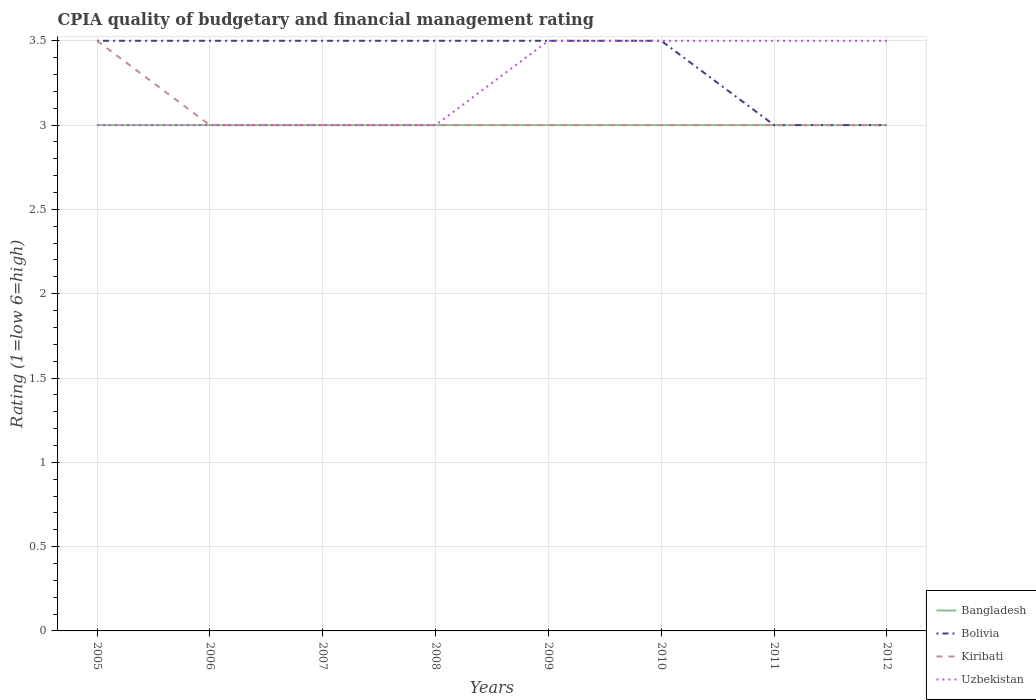How many different coloured lines are there?
Offer a terse response. 4. Does the line corresponding to Uzbekistan intersect with the line corresponding to Bolivia?
Provide a short and direct response. Yes. Across all years, what is the maximum CPIA rating in Kiribati?
Make the answer very short. 3. Is the CPIA rating in Uzbekistan strictly greater than the CPIA rating in Bangladesh over the years?
Provide a succinct answer. No. Are the values on the major ticks of Y-axis written in scientific E-notation?
Offer a terse response. No. Does the graph contain grids?
Provide a succinct answer. Yes. How many legend labels are there?
Provide a succinct answer. 4. What is the title of the graph?
Ensure brevity in your answer.  CPIA quality of budgetary and financial management rating. Does "Argentina" appear as one of the legend labels in the graph?
Make the answer very short. No. What is the label or title of the Y-axis?
Provide a succinct answer. Rating (1=low 6=high). What is the Rating (1=low 6=high) of Bangladesh in 2005?
Provide a succinct answer. 3. What is the Rating (1=low 6=high) in Kiribati in 2005?
Keep it short and to the point. 3.5. What is the Rating (1=low 6=high) of Uzbekistan in 2005?
Ensure brevity in your answer.  3. What is the Rating (1=low 6=high) in Bangladesh in 2006?
Your answer should be very brief. 3. What is the Rating (1=low 6=high) of Uzbekistan in 2006?
Provide a short and direct response. 3. What is the Rating (1=low 6=high) of Bolivia in 2007?
Offer a terse response. 3.5. What is the Rating (1=low 6=high) of Kiribati in 2009?
Give a very brief answer. 3. What is the Rating (1=low 6=high) of Uzbekistan in 2009?
Provide a short and direct response. 3.5. What is the Rating (1=low 6=high) in Bangladesh in 2011?
Make the answer very short. 3. What is the Rating (1=low 6=high) in Kiribati in 2011?
Provide a succinct answer. 3. What is the Rating (1=low 6=high) of Bangladesh in 2012?
Your answer should be very brief. 3. What is the Rating (1=low 6=high) in Bolivia in 2012?
Offer a terse response. 3. Across all years, what is the maximum Rating (1=low 6=high) in Bangladesh?
Your response must be concise. 3. Across all years, what is the maximum Rating (1=low 6=high) in Bolivia?
Ensure brevity in your answer.  3.5. What is the total Rating (1=low 6=high) of Bangladesh in the graph?
Provide a short and direct response. 24. What is the total Rating (1=low 6=high) in Kiribati in the graph?
Provide a short and direct response. 24.5. What is the total Rating (1=low 6=high) in Uzbekistan in the graph?
Offer a very short reply. 26. What is the difference between the Rating (1=low 6=high) of Bangladesh in 2005 and that in 2006?
Your answer should be compact. 0. What is the difference between the Rating (1=low 6=high) in Bolivia in 2005 and that in 2007?
Keep it short and to the point. 0. What is the difference between the Rating (1=low 6=high) of Kiribati in 2005 and that in 2007?
Provide a short and direct response. 0.5. What is the difference between the Rating (1=low 6=high) of Bangladesh in 2005 and that in 2008?
Provide a succinct answer. 0. What is the difference between the Rating (1=low 6=high) in Uzbekistan in 2005 and that in 2008?
Ensure brevity in your answer.  0. What is the difference between the Rating (1=low 6=high) of Bangladesh in 2005 and that in 2009?
Provide a short and direct response. 0. What is the difference between the Rating (1=low 6=high) of Uzbekistan in 2005 and that in 2009?
Provide a succinct answer. -0.5. What is the difference between the Rating (1=low 6=high) in Kiribati in 2005 and that in 2010?
Provide a succinct answer. 0.5. What is the difference between the Rating (1=low 6=high) in Uzbekistan in 2005 and that in 2010?
Ensure brevity in your answer.  -0.5. What is the difference between the Rating (1=low 6=high) of Uzbekistan in 2005 and that in 2011?
Offer a very short reply. -0.5. What is the difference between the Rating (1=low 6=high) in Bangladesh in 2005 and that in 2012?
Your answer should be compact. 0. What is the difference between the Rating (1=low 6=high) of Bolivia in 2005 and that in 2012?
Provide a short and direct response. 0.5. What is the difference between the Rating (1=low 6=high) of Bangladesh in 2006 and that in 2007?
Offer a very short reply. 0. What is the difference between the Rating (1=low 6=high) in Bolivia in 2006 and that in 2007?
Offer a terse response. 0. What is the difference between the Rating (1=low 6=high) of Kiribati in 2006 and that in 2007?
Keep it short and to the point. 0. What is the difference between the Rating (1=low 6=high) in Kiribati in 2006 and that in 2008?
Ensure brevity in your answer.  0. What is the difference between the Rating (1=low 6=high) in Uzbekistan in 2006 and that in 2008?
Offer a very short reply. 0. What is the difference between the Rating (1=low 6=high) in Bangladesh in 2006 and that in 2009?
Offer a very short reply. 0. What is the difference between the Rating (1=low 6=high) of Bolivia in 2006 and that in 2009?
Offer a terse response. 0. What is the difference between the Rating (1=low 6=high) in Uzbekistan in 2006 and that in 2009?
Your response must be concise. -0.5. What is the difference between the Rating (1=low 6=high) in Bolivia in 2006 and that in 2010?
Ensure brevity in your answer.  0. What is the difference between the Rating (1=low 6=high) in Uzbekistan in 2006 and that in 2011?
Keep it short and to the point. -0.5. What is the difference between the Rating (1=low 6=high) in Bangladesh in 2006 and that in 2012?
Your answer should be compact. 0. What is the difference between the Rating (1=low 6=high) of Kiribati in 2006 and that in 2012?
Offer a terse response. 0. What is the difference between the Rating (1=low 6=high) in Bangladesh in 2007 and that in 2008?
Offer a terse response. 0. What is the difference between the Rating (1=low 6=high) in Bolivia in 2007 and that in 2008?
Your response must be concise. 0. What is the difference between the Rating (1=low 6=high) in Uzbekistan in 2007 and that in 2008?
Ensure brevity in your answer.  0. What is the difference between the Rating (1=low 6=high) of Bolivia in 2007 and that in 2009?
Provide a succinct answer. 0. What is the difference between the Rating (1=low 6=high) of Kiribati in 2007 and that in 2009?
Your response must be concise. 0. What is the difference between the Rating (1=low 6=high) in Uzbekistan in 2007 and that in 2009?
Your response must be concise. -0.5. What is the difference between the Rating (1=low 6=high) of Kiribati in 2007 and that in 2010?
Make the answer very short. 0. What is the difference between the Rating (1=low 6=high) of Bangladesh in 2007 and that in 2011?
Your answer should be very brief. 0. What is the difference between the Rating (1=low 6=high) of Bolivia in 2007 and that in 2011?
Keep it short and to the point. 0.5. What is the difference between the Rating (1=low 6=high) of Kiribati in 2007 and that in 2011?
Offer a terse response. 0. What is the difference between the Rating (1=low 6=high) of Uzbekistan in 2007 and that in 2011?
Your response must be concise. -0.5. What is the difference between the Rating (1=low 6=high) of Bangladesh in 2007 and that in 2012?
Your answer should be very brief. 0. What is the difference between the Rating (1=low 6=high) of Bolivia in 2007 and that in 2012?
Give a very brief answer. 0.5. What is the difference between the Rating (1=low 6=high) of Kiribati in 2007 and that in 2012?
Provide a short and direct response. 0. What is the difference between the Rating (1=low 6=high) of Bolivia in 2008 and that in 2009?
Ensure brevity in your answer.  0. What is the difference between the Rating (1=low 6=high) in Kiribati in 2008 and that in 2009?
Give a very brief answer. 0. What is the difference between the Rating (1=low 6=high) of Uzbekistan in 2008 and that in 2009?
Ensure brevity in your answer.  -0.5. What is the difference between the Rating (1=low 6=high) in Uzbekistan in 2008 and that in 2010?
Your response must be concise. -0.5. What is the difference between the Rating (1=low 6=high) in Bangladesh in 2008 and that in 2011?
Provide a short and direct response. 0. What is the difference between the Rating (1=low 6=high) of Uzbekistan in 2008 and that in 2011?
Provide a succinct answer. -0.5. What is the difference between the Rating (1=low 6=high) in Bolivia in 2008 and that in 2012?
Make the answer very short. 0.5. What is the difference between the Rating (1=low 6=high) of Bolivia in 2009 and that in 2010?
Ensure brevity in your answer.  0. What is the difference between the Rating (1=low 6=high) in Bangladesh in 2009 and that in 2011?
Ensure brevity in your answer.  0. What is the difference between the Rating (1=low 6=high) of Bolivia in 2009 and that in 2011?
Keep it short and to the point. 0.5. What is the difference between the Rating (1=low 6=high) of Uzbekistan in 2009 and that in 2011?
Make the answer very short. 0. What is the difference between the Rating (1=low 6=high) of Bangladesh in 2009 and that in 2012?
Provide a short and direct response. 0. What is the difference between the Rating (1=low 6=high) in Bolivia in 2009 and that in 2012?
Provide a short and direct response. 0.5. What is the difference between the Rating (1=low 6=high) of Uzbekistan in 2009 and that in 2012?
Offer a terse response. 0. What is the difference between the Rating (1=low 6=high) in Bolivia in 2010 and that in 2011?
Provide a succinct answer. 0.5. What is the difference between the Rating (1=low 6=high) of Kiribati in 2010 and that in 2011?
Ensure brevity in your answer.  0. What is the difference between the Rating (1=low 6=high) in Uzbekistan in 2010 and that in 2011?
Offer a very short reply. 0. What is the difference between the Rating (1=low 6=high) in Kiribati in 2010 and that in 2012?
Make the answer very short. 0. What is the difference between the Rating (1=low 6=high) in Uzbekistan in 2010 and that in 2012?
Ensure brevity in your answer.  0. What is the difference between the Rating (1=low 6=high) of Bangladesh in 2011 and that in 2012?
Provide a short and direct response. 0. What is the difference between the Rating (1=low 6=high) in Bolivia in 2011 and that in 2012?
Offer a very short reply. 0. What is the difference between the Rating (1=low 6=high) in Uzbekistan in 2011 and that in 2012?
Provide a succinct answer. 0. What is the difference between the Rating (1=low 6=high) in Bangladesh in 2005 and the Rating (1=low 6=high) in Bolivia in 2006?
Your answer should be compact. -0.5. What is the difference between the Rating (1=low 6=high) in Bangladesh in 2005 and the Rating (1=low 6=high) in Kiribati in 2006?
Make the answer very short. 0. What is the difference between the Rating (1=low 6=high) of Bangladesh in 2005 and the Rating (1=low 6=high) of Uzbekistan in 2006?
Your answer should be compact. 0. What is the difference between the Rating (1=low 6=high) in Bolivia in 2005 and the Rating (1=low 6=high) in Uzbekistan in 2006?
Offer a very short reply. 0.5. What is the difference between the Rating (1=low 6=high) in Kiribati in 2005 and the Rating (1=low 6=high) in Uzbekistan in 2006?
Provide a short and direct response. 0.5. What is the difference between the Rating (1=low 6=high) in Bangladesh in 2005 and the Rating (1=low 6=high) in Bolivia in 2007?
Keep it short and to the point. -0.5. What is the difference between the Rating (1=low 6=high) in Bolivia in 2005 and the Rating (1=low 6=high) in Kiribati in 2007?
Your answer should be very brief. 0.5. What is the difference between the Rating (1=low 6=high) in Bangladesh in 2005 and the Rating (1=low 6=high) in Kiribati in 2008?
Offer a terse response. 0. What is the difference between the Rating (1=low 6=high) in Bolivia in 2005 and the Rating (1=low 6=high) in Kiribati in 2008?
Your answer should be compact. 0.5. What is the difference between the Rating (1=low 6=high) of Bangladesh in 2005 and the Rating (1=low 6=high) of Kiribati in 2009?
Your answer should be compact. 0. What is the difference between the Rating (1=low 6=high) of Bangladesh in 2005 and the Rating (1=low 6=high) of Uzbekistan in 2009?
Keep it short and to the point. -0.5. What is the difference between the Rating (1=low 6=high) in Bolivia in 2005 and the Rating (1=low 6=high) in Uzbekistan in 2009?
Keep it short and to the point. 0. What is the difference between the Rating (1=low 6=high) in Bangladesh in 2005 and the Rating (1=low 6=high) in Kiribati in 2010?
Your response must be concise. 0. What is the difference between the Rating (1=low 6=high) in Bolivia in 2005 and the Rating (1=low 6=high) in Kiribati in 2010?
Your answer should be very brief. 0.5. What is the difference between the Rating (1=low 6=high) of Bolivia in 2005 and the Rating (1=low 6=high) of Uzbekistan in 2010?
Offer a terse response. 0. What is the difference between the Rating (1=low 6=high) in Bangladesh in 2005 and the Rating (1=low 6=high) in Bolivia in 2011?
Ensure brevity in your answer.  0. What is the difference between the Rating (1=low 6=high) in Bangladesh in 2005 and the Rating (1=low 6=high) in Kiribati in 2011?
Offer a terse response. 0. What is the difference between the Rating (1=low 6=high) of Bolivia in 2005 and the Rating (1=low 6=high) of Kiribati in 2011?
Offer a terse response. 0.5. What is the difference between the Rating (1=low 6=high) in Kiribati in 2005 and the Rating (1=low 6=high) in Uzbekistan in 2011?
Ensure brevity in your answer.  0. What is the difference between the Rating (1=low 6=high) in Bangladesh in 2005 and the Rating (1=low 6=high) in Bolivia in 2012?
Offer a very short reply. 0. What is the difference between the Rating (1=low 6=high) of Bangladesh in 2005 and the Rating (1=low 6=high) of Uzbekistan in 2012?
Provide a succinct answer. -0.5. What is the difference between the Rating (1=low 6=high) of Bolivia in 2005 and the Rating (1=low 6=high) of Uzbekistan in 2012?
Offer a terse response. 0. What is the difference between the Rating (1=low 6=high) of Kiribati in 2005 and the Rating (1=low 6=high) of Uzbekistan in 2012?
Offer a terse response. 0. What is the difference between the Rating (1=low 6=high) of Bangladesh in 2006 and the Rating (1=low 6=high) of Uzbekistan in 2007?
Your response must be concise. 0. What is the difference between the Rating (1=low 6=high) of Bolivia in 2006 and the Rating (1=low 6=high) of Kiribati in 2007?
Offer a terse response. 0.5. What is the difference between the Rating (1=low 6=high) of Bolivia in 2006 and the Rating (1=low 6=high) of Uzbekistan in 2007?
Your answer should be very brief. 0.5. What is the difference between the Rating (1=low 6=high) of Bangladesh in 2006 and the Rating (1=low 6=high) of Bolivia in 2008?
Make the answer very short. -0.5. What is the difference between the Rating (1=low 6=high) of Bangladesh in 2006 and the Rating (1=low 6=high) of Uzbekistan in 2008?
Offer a terse response. 0. What is the difference between the Rating (1=low 6=high) of Bolivia in 2006 and the Rating (1=low 6=high) of Kiribati in 2008?
Your answer should be very brief. 0.5. What is the difference between the Rating (1=low 6=high) in Bolivia in 2006 and the Rating (1=low 6=high) in Uzbekistan in 2008?
Your answer should be very brief. 0.5. What is the difference between the Rating (1=low 6=high) in Bangladesh in 2006 and the Rating (1=low 6=high) in Bolivia in 2009?
Offer a terse response. -0.5. What is the difference between the Rating (1=low 6=high) in Bangladesh in 2006 and the Rating (1=low 6=high) in Kiribati in 2009?
Your answer should be very brief. 0. What is the difference between the Rating (1=low 6=high) of Bolivia in 2006 and the Rating (1=low 6=high) of Uzbekistan in 2009?
Provide a succinct answer. 0. What is the difference between the Rating (1=low 6=high) of Kiribati in 2006 and the Rating (1=low 6=high) of Uzbekistan in 2009?
Give a very brief answer. -0.5. What is the difference between the Rating (1=low 6=high) of Bolivia in 2006 and the Rating (1=low 6=high) of Uzbekistan in 2010?
Make the answer very short. 0. What is the difference between the Rating (1=low 6=high) in Bangladesh in 2006 and the Rating (1=low 6=high) in Kiribati in 2011?
Keep it short and to the point. 0. What is the difference between the Rating (1=low 6=high) in Bangladesh in 2006 and the Rating (1=low 6=high) in Uzbekistan in 2011?
Offer a very short reply. -0.5. What is the difference between the Rating (1=low 6=high) in Bolivia in 2006 and the Rating (1=low 6=high) in Kiribati in 2011?
Your answer should be compact. 0.5. What is the difference between the Rating (1=low 6=high) of Bolivia in 2006 and the Rating (1=low 6=high) of Uzbekistan in 2011?
Keep it short and to the point. 0. What is the difference between the Rating (1=low 6=high) in Bangladesh in 2006 and the Rating (1=low 6=high) in Kiribati in 2012?
Make the answer very short. 0. What is the difference between the Rating (1=low 6=high) of Bangladesh in 2006 and the Rating (1=low 6=high) of Uzbekistan in 2012?
Your response must be concise. -0.5. What is the difference between the Rating (1=low 6=high) of Bolivia in 2006 and the Rating (1=low 6=high) of Kiribati in 2012?
Ensure brevity in your answer.  0.5. What is the difference between the Rating (1=low 6=high) of Bolivia in 2006 and the Rating (1=low 6=high) of Uzbekistan in 2012?
Make the answer very short. 0. What is the difference between the Rating (1=low 6=high) in Kiribati in 2007 and the Rating (1=low 6=high) in Uzbekistan in 2008?
Your answer should be very brief. 0. What is the difference between the Rating (1=low 6=high) in Bangladesh in 2007 and the Rating (1=low 6=high) in Bolivia in 2009?
Keep it short and to the point. -0.5. What is the difference between the Rating (1=low 6=high) of Bangladesh in 2007 and the Rating (1=low 6=high) of Kiribati in 2009?
Your answer should be very brief. 0. What is the difference between the Rating (1=low 6=high) of Bangladesh in 2007 and the Rating (1=low 6=high) of Uzbekistan in 2009?
Your answer should be compact. -0.5. What is the difference between the Rating (1=low 6=high) in Bangladesh in 2007 and the Rating (1=low 6=high) in Uzbekistan in 2010?
Offer a very short reply. -0.5. What is the difference between the Rating (1=low 6=high) of Bolivia in 2007 and the Rating (1=low 6=high) of Uzbekistan in 2010?
Offer a very short reply. 0. What is the difference between the Rating (1=low 6=high) in Bangladesh in 2007 and the Rating (1=low 6=high) in Bolivia in 2011?
Offer a very short reply. 0. What is the difference between the Rating (1=low 6=high) of Bangladesh in 2007 and the Rating (1=low 6=high) of Kiribati in 2011?
Keep it short and to the point. 0. What is the difference between the Rating (1=low 6=high) in Bolivia in 2007 and the Rating (1=low 6=high) in Uzbekistan in 2011?
Keep it short and to the point. 0. What is the difference between the Rating (1=low 6=high) of Bangladesh in 2007 and the Rating (1=low 6=high) of Bolivia in 2012?
Provide a succinct answer. 0. What is the difference between the Rating (1=low 6=high) in Bangladesh in 2007 and the Rating (1=low 6=high) in Uzbekistan in 2012?
Your answer should be very brief. -0.5. What is the difference between the Rating (1=low 6=high) of Bolivia in 2007 and the Rating (1=low 6=high) of Kiribati in 2012?
Offer a very short reply. 0.5. What is the difference between the Rating (1=low 6=high) in Bolivia in 2007 and the Rating (1=low 6=high) in Uzbekistan in 2012?
Your answer should be very brief. 0. What is the difference between the Rating (1=low 6=high) of Bangladesh in 2008 and the Rating (1=low 6=high) of Bolivia in 2009?
Ensure brevity in your answer.  -0.5. What is the difference between the Rating (1=low 6=high) in Bangladesh in 2008 and the Rating (1=low 6=high) in Kiribati in 2009?
Your answer should be very brief. 0. What is the difference between the Rating (1=low 6=high) of Bangladesh in 2008 and the Rating (1=low 6=high) of Uzbekistan in 2009?
Keep it short and to the point. -0.5. What is the difference between the Rating (1=low 6=high) of Bolivia in 2008 and the Rating (1=low 6=high) of Kiribati in 2009?
Offer a terse response. 0.5. What is the difference between the Rating (1=low 6=high) of Bolivia in 2008 and the Rating (1=low 6=high) of Uzbekistan in 2009?
Make the answer very short. 0. What is the difference between the Rating (1=low 6=high) of Kiribati in 2008 and the Rating (1=low 6=high) of Uzbekistan in 2009?
Keep it short and to the point. -0.5. What is the difference between the Rating (1=low 6=high) of Bangladesh in 2008 and the Rating (1=low 6=high) of Bolivia in 2010?
Give a very brief answer. -0.5. What is the difference between the Rating (1=low 6=high) of Bangladesh in 2008 and the Rating (1=low 6=high) of Kiribati in 2010?
Keep it short and to the point. 0. What is the difference between the Rating (1=low 6=high) in Kiribati in 2008 and the Rating (1=low 6=high) in Uzbekistan in 2010?
Keep it short and to the point. -0.5. What is the difference between the Rating (1=low 6=high) in Bangladesh in 2008 and the Rating (1=low 6=high) in Bolivia in 2011?
Your answer should be very brief. 0. What is the difference between the Rating (1=low 6=high) of Bangladesh in 2008 and the Rating (1=low 6=high) of Uzbekistan in 2011?
Make the answer very short. -0.5. What is the difference between the Rating (1=low 6=high) of Bolivia in 2008 and the Rating (1=low 6=high) of Uzbekistan in 2011?
Provide a short and direct response. 0. What is the difference between the Rating (1=low 6=high) of Kiribati in 2008 and the Rating (1=low 6=high) of Uzbekistan in 2011?
Your response must be concise. -0.5. What is the difference between the Rating (1=low 6=high) in Bangladesh in 2008 and the Rating (1=low 6=high) in Uzbekistan in 2012?
Your answer should be very brief. -0.5. What is the difference between the Rating (1=low 6=high) of Bolivia in 2008 and the Rating (1=low 6=high) of Uzbekistan in 2012?
Make the answer very short. 0. What is the difference between the Rating (1=low 6=high) in Bangladesh in 2009 and the Rating (1=low 6=high) in Kiribati in 2010?
Provide a succinct answer. 0. What is the difference between the Rating (1=low 6=high) of Bolivia in 2009 and the Rating (1=low 6=high) of Uzbekistan in 2010?
Keep it short and to the point. 0. What is the difference between the Rating (1=low 6=high) of Kiribati in 2009 and the Rating (1=low 6=high) of Uzbekistan in 2010?
Offer a very short reply. -0.5. What is the difference between the Rating (1=low 6=high) of Bangladesh in 2009 and the Rating (1=low 6=high) of Bolivia in 2011?
Make the answer very short. 0. What is the difference between the Rating (1=low 6=high) of Bangladesh in 2009 and the Rating (1=low 6=high) of Kiribati in 2011?
Keep it short and to the point. 0. What is the difference between the Rating (1=low 6=high) of Bangladesh in 2009 and the Rating (1=low 6=high) of Uzbekistan in 2011?
Make the answer very short. -0.5. What is the difference between the Rating (1=low 6=high) in Bangladesh in 2009 and the Rating (1=low 6=high) in Kiribati in 2012?
Ensure brevity in your answer.  0. What is the difference between the Rating (1=low 6=high) of Bangladesh in 2009 and the Rating (1=low 6=high) of Uzbekistan in 2012?
Keep it short and to the point. -0.5. What is the difference between the Rating (1=low 6=high) of Bolivia in 2009 and the Rating (1=low 6=high) of Uzbekistan in 2012?
Ensure brevity in your answer.  0. What is the difference between the Rating (1=low 6=high) of Bangladesh in 2010 and the Rating (1=low 6=high) of Bolivia in 2011?
Provide a short and direct response. 0. What is the difference between the Rating (1=low 6=high) in Bangladesh in 2010 and the Rating (1=low 6=high) in Kiribati in 2011?
Offer a very short reply. 0. What is the difference between the Rating (1=low 6=high) in Bolivia in 2010 and the Rating (1=low 6=high) in Kiribati in 2011?
Make the answer very short. 0.5. What is the difference between the Rating (1=low 6=high) in Bangladesh in 2010 and the Rating (1=low 6=high) in Kiribati in 2012?
Provide a short and direct response. 0. What is the difference between the Rating (1=low 6=high) in Bangladesh in 2010 and the Rating (1=low 6=high) in Uzbekistan in 2012?
Your response must be concise. -0.5. What is the difference between the Rating (1=low 6=high) in Bolivia in 2010 and the Rating (1=low 6=high) in Uzbekistan in 2012?
Your answer should be very brief. 0. What is the difference between the Rating (1=low 6=high) in Bangladesh in 2011 and the Rating (1=low 6=high) in Kiribati in 2012?
Your response must be concise. 0. What is the difference between the Rating (1=low 6=high) of Bangladesh in 2011 and the Rating (1=low 6=high) of Uzbekistan in 2012?
Your response must be concise. -0.5. What is the difference between the Rating (1=low 6=high) in Bolivia in 2011 and the Rating (1=low 6=high) in Kiribati in 2012?
Provide a short and direct response. 0. What is the difference between the Rating (1=low 6=high) of Bolivia in 2011 and the Rating (1=low 6=high) of Uzbekistan in 2012?
Your response must be concise. -0.5. What is the average Rating (1=low 6=high) of Bangladesh per year?
Provide a succinct answer. 3. What is the average Rating (1=low 6=high) of Bolivia per year?
Your response must be concise. 3.38. What is the average Rating (1=low 6=high) of Kiribati per year?
Keep it short and to the point. 3.06. In the year 2005, what is the difference between the Rating (1=low 6=high) of Bangladesh and Rating (1=low 6=high) of Uzbekistan?
Offer a very short reply. 0. In the year 2005, what is the difference between the Rating (1=low 6=high) of Bolivia and Rating (1=low 6=high) of Kiribati?
Keep it short and to the point. 0. In the year 2005, what is the difference between the Rating (1=low 6=high) in Bolivia and Rating (1=low 6=high) in Uzbekistan?
Provide a short and direct response. 0.5. In the year 2005, what is the difference between the Rating (1=low 6=high) in Kiribati and Rating (1=low 6=high) in Uzbekistan?
Make the answer very short. 0.5. In the year 2006, what is the difference between the Rating (1=low 6=high) in Bolivia and Rating (1=low 6=high) in Uzbekistan?
Your answer should be very brief. 0.5. In the year 2006, what is the difference between the Rating (1=low 6=high) of Kiribati and Rating (1=low 6=high) of Uzbekistan?
Give a very brief answer. 0. In the year 2007, what is the difference between the Rating (1=low 6=high) of Bangladesh and Rating (1=low 6=high) of Bolivia?
Your response must be concise. -0.5. In the year 2007, what is the difference between the Rating (1=low 6=high) in Bangladesh and Rating (1=low 6=high) in Kiribati?
Give a very brief answer. 0. In the year 2007, what is the difference between the Rating (1=low 6=high) in Bolivia and Rating (1=low 6=high) in Uzbekistan?
Your answer should be very brief. 0.5. In the year 2008, what is the difference between the Rating (1=low 6=high) in Bangladesh and Rating (1=low 6=high) in Bolivia?
Your answer should be compact. -0.5. In the year 2008, what is the difference between the Rating (1=low 6=high) in Bangladesh and Rating (1=low 6=high) in Uzbekistan?
Your answer should be very brief. 0. In the year 2008, what is the difference between the Rating (1=low 6=high) of Bolivia and Rating (1=low 6=high) of Kiribati?
Give a very brief answer. 0.5. In the year 2008, what is the difference between the Rating (1=low 6=high) of Kiribati and Rating (1=low 6=high) of Uzbekistan?
Provide a short and direct response. 0. In the year 2009, what is the difference between the Rating (1=low 6=high) of Bangladesh and Rating (1=low 6=high) of Bolivia?
Provide a short and direct response. -0.5. In the year 2010, what is the difference between the Rating (1=low 6=high) in Bangladesh and Rating (1=low 6=high) in Bolivia?
Offer a very short reply. -0.5. In the year 2010, what is the difference between the Rating (1=low 6=high) of Bangladesh and Rating (1=low 6=high) of Kiribati?
Provide a succinct answer. 0. In the year 2010, what is the difference between the Rating (1=low 6=high) of Bolivia and Rating (1=low 6=high) of Uzbekistan?
Your response must be concise. 0. In the year 2010, what is the difference between the Rating (1=low 6=high) in Kiribati and Rating (1=low 6=high) in Uzbekistan?
Your answer should be compact. -0.5. In the year 2011, what is the difference between the Rating (1=low 6=high) in Kiribati and Rating (1=low 6=high) in Uzbekistan?
Your answer should be compact. -0.5. In the year 2012, what is the difference between the Rating (1=low 6=high) in Bangladesh and Rating (1=low 6=high) in Bolivia?
Offer a very short reply. 0. In the year 2012, what is the difference between the Rating (1=low 6=high) in Bangladesh and Rating (1=low 6=high) in Uzbekistan?
Your response must be concise. -0.5. In the year 2012, what is the difference between the Rating (1=low 6=high) in Bolivia and Rating (1=low 6=high) in Kiribati?
Provide a short and direct response. 0. In the year 2012, what is the difference between the Rating (1=low 6=high) of Kiribati and Rating (1=low 6=high) of Uzbekistan?
Offer a terse response. -0.5. What is the ratio of the Rating (1=low 6=high) of Kiribati in 2005 to that in 2006?
Offer a very short reply. 1.17. What is the ratio of the Rating (1=low 6=high) of Uzbekistan in 2005 to that in 2006?
Provide a succinct answer. 1. What is the ratio of the Rating (1=low 6=high) in Bangladesh in 2005 to that in 2007?
Provide a short and direct response. 1. What is the ratio of the Rating (1=low 6=high) in Bolivia in 2005 to that in 2007?
Offer a very short reply. 1. What is the ratio of the Rating (1=low 6=high) of Kiribati in 2005 to that in 2007?
Offer a very short reply. 1.17. What is the ratio of the Rating (1=low 6=high) in Bangladesh in 2005 to that in 2008?
Give a very brief answer. 1. What is the ratio of the Rating (1=low 6=high) of Bolivia in 2005 to that in 2008?
Give a very brief answer. 1. What is the ratio of the Rating (1=low 6=high) of Kiribati in 2005 to that in 2008?
Your answer should be compact. 1.17. What is the ratio of the Rating (1=low 6=high) in Uzbekistan in 2005 to that in 2008?
Offer a very short reply. 1. What is the ratio of the Rating (1=low 6=high) in Bangladesh in 2005 to that in 2009?
Your answer should be compact. 1. What is the ratio of the Rating (1=low 6=high) of Kiribati in 2005 to that in 2009?
Offer a very short reply. 1.17. What is the ratio of the Rating (1=low 6=high) in Uzbekistan in 2005 to that in 2009?
Your response must be concise. 0.86. What is the ratio of the Rating (1=low 6=high) of Bolivia in 2005 to that in 2010?
Your answer should be very brief. 1. What is the ratio of the Rating (1=low 6=high) of Kiribati in 2005 to that in 2010?
Provide a succinct answer. 1.17. What is the ratio of the Rating (1=low 6=high) in Uzbekistan in 2005 to that in 2010?
Offer a very short reply. 0.86. What is the ratio of the Rating (1=low 6=high) in Bangladesh in 2005 to that in 2011?
Give a very brief answer. 1. What is the ratio of the Rating (1=low 6=high) in Kiribati in 2005 to that in 2011?
Your response must be concise. 1.17. What is the ratio of the Rating (1=low 6=high) of Uzbekistan in 2005 to that in 2011?
Your answer should be compact. 0.86. What is the ratio of the Rating (1=low 6=high) in Kiribati in 2005 to that in 2012?
Your answer should be compact. 1.17. What is the ratio of the Rating (1=low 6=high) of Bangladesh in 2006 to that in 2008?
Ensure brevity in your answer.  1. What is the ratio of the Rating (1=low 6=high) in Uzbekistan in 2006 to that in 2008?
Provide a succinct answer. 1. What is the ratio of the Rating (1=low 6=high) in Bolivia in 2006 to that in 2009?
Your answer should be very brief. 1. What is the ratio of the Rating (1=low 6=high) of Uzbekistan in 2006 to that in 2009?
Your answer should be compact. 0.86. What is the ratio of the Rating (1=low 6=high) of Bolivia in 2006 to that in 2010?
Your response must be concise. 1. What is the ratio of the Rating (1=low 6=high) in Uzbekistan in 2006 to that in 2010?
Your answer should be compact. 0.86. What is the ratio of the Rating (1=low 6=high) of Bolivia in 2006 to that in 2011?
Your answer should be very brief. 1.17. What is the ratio of the Rating (1=low 6=high) of Kiribati in 2006 to that in 2011?
Provide a short and direct response. 1. What is the ratio of the Rating (1=low 6=high) of Uzbekistan in 2006 to that in 2011?
Offer a terse response. 0.86. What is the ratio of the Rating (1=low 6=high) of Bolivia in 2007 to that in 2008?
Make the answer very short. 1. What is the ratio of the Rating (1=low 6=high) in Kiribati in 2007 to that in 2008?
Provide a succinct answer. 1. What is the ratio of the Rating (1=low 6=high) of Uzbekistan in 2007 to that in 2008?
Offer a terse response. 1. What is the ratio of the Rating (1=low 6=high) in Bolivia in 2007 to that in 2009?
Keep it short and to the point. 1. What is the ratio of the Rating (1=low 6=high) of Kiribati in 2007 to that in 2009?
Make the answer very short. 1. What is the ratio of the Rating (1=low 6=high) of Bangladesh in 2007 to that in 2010?
Ensure brevity in your answer.  1. What is the ratio of the Rating (1=low 6=high) of Kiribati in 2007 to that in 2010?
Ensure brevity in your answer.  1. What is the ratio of the Rating (1=low 6=high) of Uzbekistan in 2007 to that in 2010?
Your answer should be very brief. 0.86. What is the ratio of the Rating (1=low 6=high) of Kiribati in 2007 to that in 2011?
Your response must be concise. 1. What is the ratio of the Rating (1=low 6=high) of Uzbekistan in 2007 to that in 2011?
Provide a succinct answer. 0.86. What is the ratio of the Rating (1=low 6=high) in Bangladesh in 2007 to that in 2012?
Your answer should be very brief. 1. What is the ratio of the Rating (1=low 6=high) in Kiribati in 2007 to that in 2012?
Your response must be concise. 1. What is the ratio of the Rating (1=low 6=high) in Uzbekistan in 2007 to that in 2012?
Offer a terse response. 0.86. What is the ratio of the Rating (1=low 6=high) in Bangladesh in 2008 to that in 2009?
Give a very brief answer. 1. What is the ratio of the Rating (1=low 6=high) of Bolivia in 2008 to that in 2009?
Ensure brevity in your answer.  1. What is the ratio of the Rating (1=low 6=high) in Uzbekistan in 2008 to that in 2009?
Offer a terse response. 0.86. What is the ratio of the Rating (1=low 6=high) in Bolivia in 2008 to that in 2010?
Make the answer very short. 1. What is the ratio of the Rating (1=low 6=high) in Bangladesh in 2008 to that in 2011?
Give a very brief answer. 1. What is the ratio of the Rating (1=low 6=high) of Bolivia in 2008 to that in 2011?
Provide a succinct answer. 1.17. What is the ratio of the Rating (1=low 6=high) of Bolivia in 2008 to that in 2012?
Keep it short and to the point. 1.17. What is the ratio of the Rating (1=low 6=high) in Uzbekistan in 2008 to that in 2012?
Ensure brevity in your answer.  0.86. What is the ratio of the Rating (1=low 6=high) in Bangladesh in 2009 to that in 2010?
Provide a succinct answer. 1. What is the ratio of the Rating (1=low 6=high) of Kiribati in 2009 to that in 2010?
Ensure brevity in your answer.  1. What is the ratio of the Rating (1=low 6=high) of Uzbekistan in 2009 to that in 2010?
Your response must be concise. 1. What is the ratio of the Rating (1=low 6=high) in Bangladesh in 2009 to that in 2011?
Offer a terse response. 1. What is the ratio of the Rating (1=low 6=high) in Bolivia in 2009 to that in 2011?
Offer a terse response. 1.17. What is the ratio of the Rating (1=low 6=high) in Kiribati in 2009 to that in 2011?
Offer a terse response. 1. What is the ratio of the Rating (1=low 6=high) of Kiribati in 2009 to that in 2012?
Your answer should be compact. 1. What is the ratio of the Rating (1=low 6=high) of Bolivia in 2010 to that in 2011?
Make the answer very short. 1.17. What is the ratio of the Rating (1=low 6=high) in Kiribati in 2010 to that in 2011?
Your response must be concise. 1. What is the ratio of the Rating (1=low 6=high) of Kiribati in 2010 to that in 2012?
Keep it short and to the point. 1. What is the ratio of the Rating (1=low 6=high) of Bangladesh in 2011 to that in 2012?
Offer a terse response. 1. What is the ratio of the Rating (1=low 6=high) in Kiribati in 2011 to that in 2012?
Keep it short and to the point. 1. What is the difference between the highest and the second highest Rating (1=low 6=high) in Bangladesh?
Offer a terse response. 0. What is the difference between the highest and the second highest Rating (1=low 6=high) of Bolivia?
Provide a short and direct response. 0. What is the difference between the highest and the second highest Rating (1=low 6=high) of Uzbekistan?
Give a very brief answer. 0. What is the difference between the highest and the lowest Rating (1=low 6=high) in Bangladesh?
Offer a terse response. 0. What is the difference between the highest and the lowest Rating (1=low 6=high) of Bolivia?
Your response must be concise. 0.5. What is the difference between the highest and the lowest Rating (1=low 6=high) of Uzbekistan?
Provide a succinct answer. 0.5. 